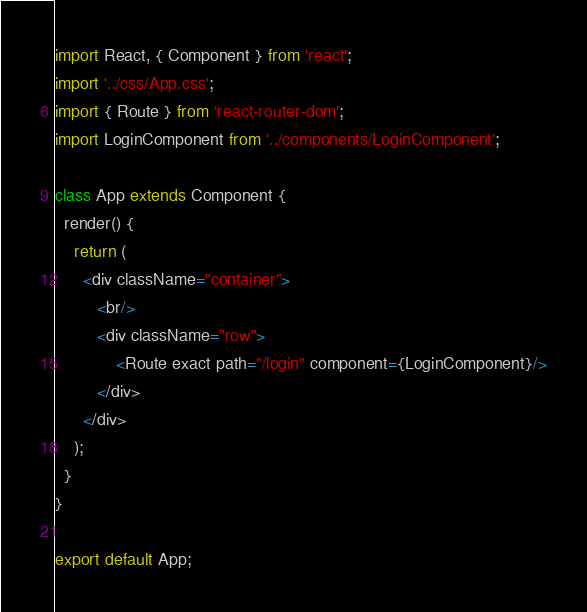<code> <loc_0><loc_0><loc_500><loc_500><_JavaScript_>import React, { Component } from 'react';
import '../css/App.css';
import { Route } from 'react-router-dom';
import LoginComponent from '../components/LoginComponent';

class App extends Component {
  render() {
    return (
      <div className="container">
         <br/>
         <div className="row">
             <Route exact path="/login" component={LoginComponent}/>
         </div>
      </div>
    );
  }
}

export default App;

</code> 